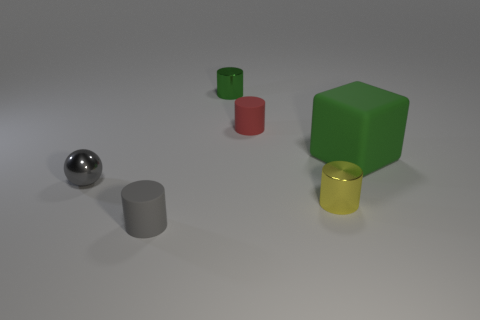Are any big green cubes visible?
Give a very brief answer. Yes. Is the number of tiny objects less than the number of objects?
Provide a succinct answer. Yes. What number of large objects are the same material as the small green thing?
Keep it short and to the point. 0. What color is the large cube that is the same material as the tiny gray cylinder?
Provide a succinct answer. Green. What shape is the large object?
Offer a terse response. Cube. How many cylinders are the same color as the metal sphere?
Your response must be concise. 1. What shape is the green metallic object that is the same size as the gray ball?
Your response must be concise. Cylinder. Is there a gray thing that has the same size as the yellow shiny object?
Offer a very short reply. Yes. What material is the red cylinder that is the same size as the gray ball?
Give a very brief answer. Rubber. What size is the green object that is in front of the metal thing behind the block?
Your response must be concise. Large. 